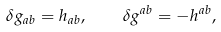Convert formula to latex. <formula><loc_0><loc_0><loc_500><loc_500>\delta g _ { a b } = h _ { a b } , \quad \delta g ^ { a b } = - h ^ { a b } ,</formula> 